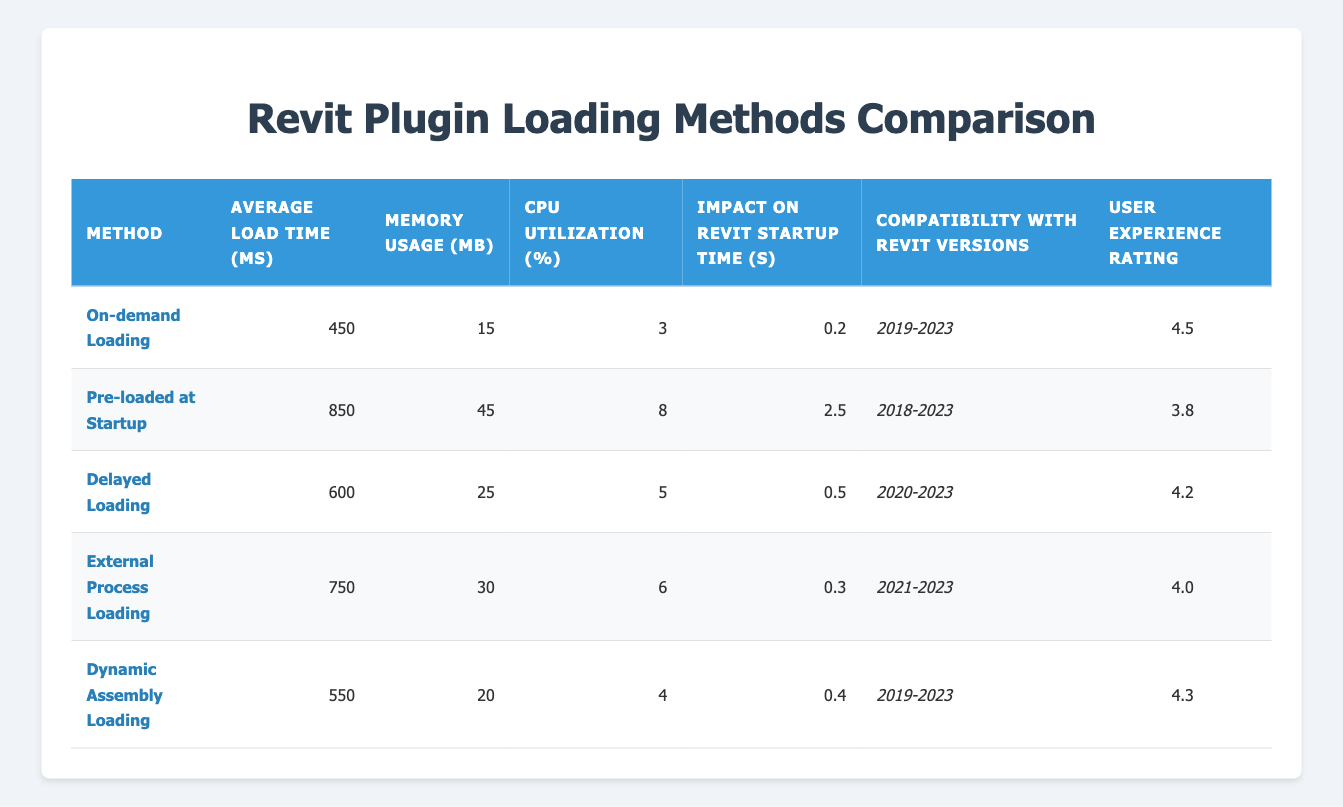What is the average load time for the "On-demand Loading" method? The table indicates that the average load time for "On-demand Loading" is 450 ms.
Answer: 450 ms Which loading method has the highest CPU utilization? By examining the table, "Pre-loaded at Startup" has the highest CPU utilization at 8%.
Answer: 8% Is "Delayed Loading" compatible with Revit versions after 2023? The compatibility for "Delayed Loading" is listed as 2020-2023, which means it does not support versions after 2023.
Answer: No What is the difference in average load time between "External Process Loading" and "Dynamic Assembly Loading"? "External Process Loading" has an average load time of 750 ms, while "Dynamic Assembly Loading" has 550 ms. Thus, the difference is 750 - 550 = 200 ms.
Answer: 200 ms Which plugin loading method has the best user experience rating? The table shows "On-demand Loading" with a user experience rating of 4.5, which is the highest among the listed methods.
Answer: 4.5 What is the average memory usage across all listed loading methods? To find the average, we sum the memory usage values: 15 + 45 + 25 + 30 + 20 = 135 MB. Then, divide by the number of methods (5), resulting in an average of 135 / 5 = 27 MB.
Answer: 27 MB Which loading method has the least impact on Revit startup time? From the table, "On-demand Loading" has the least impact with only 0.2 seconds on Revit startup time.
Answer: 0.2 seconds Is the memory usage of "Pre-loaded at Startup" method greater than the average memory usage of all methods? The memory usage for "Pre-loaded at Startup" is 45 MB, while the average memory usage calculated previously is 27 MB. Therefore, 45 MB is greater than 27 MB.
Answer: Yes What is the general trend of CPU utilization concerning memory usage across the methods? Analyzing the table, higher memory usage generally corresponds to higher CPU utilization. For instance, "On-demand Loading" uses 15 MB with 3% CPU utilization, while "Pre-loaded at Startup" uses 45 MB with 8% CPU utilization.
Answer: Higher memory usage tends to show higher CPU utilization 